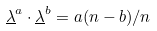Convert formula to latex. <formula><loc_0><loc_0><loc_500><loc_500>\underline { \lambda } ^ { a } \cdot \underline { \lambda } ^ { b } = a ( n - b ) / n</formula> 